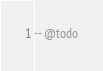Convert code to text. <code><loc_0><loc_0><loc_500><loc_500><_SQL_>-- @todo
</code> 